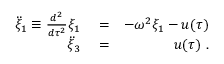<formula> <loc_0><loc_0><loc_500><loc_500>\begin{array} { r l r } { \ddot { \xi } _ { 1 } \equiv \frac { d ^ { 2 } } { d \tau ^ { 2 } } \xi _ { 1 } } & = } & { - \omega ^ { 2 } \xi _ { 1 } - u ( \tau ) } \\ { \ddot { \xi } _ { 3 } } & = } & { u ( \tau ) . } \end{array}</formula> 